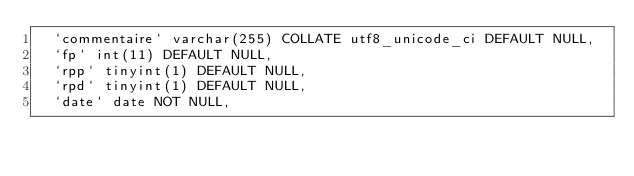Convert code to text. <code><loc_0><loc_0><loc_500><loc_500><_SQL_>  `commentaire` varchar(255) COLLATE utf8_unicode_ci DEFAULT NULL,
  `fp` int(11) DEFAULT NULL,
  `rpp` tinyint(1) DEFAULT NULL,
  `rpd` tinyint(1) DEFAULT NULL,
  `date` date NOT NULL,</code> 